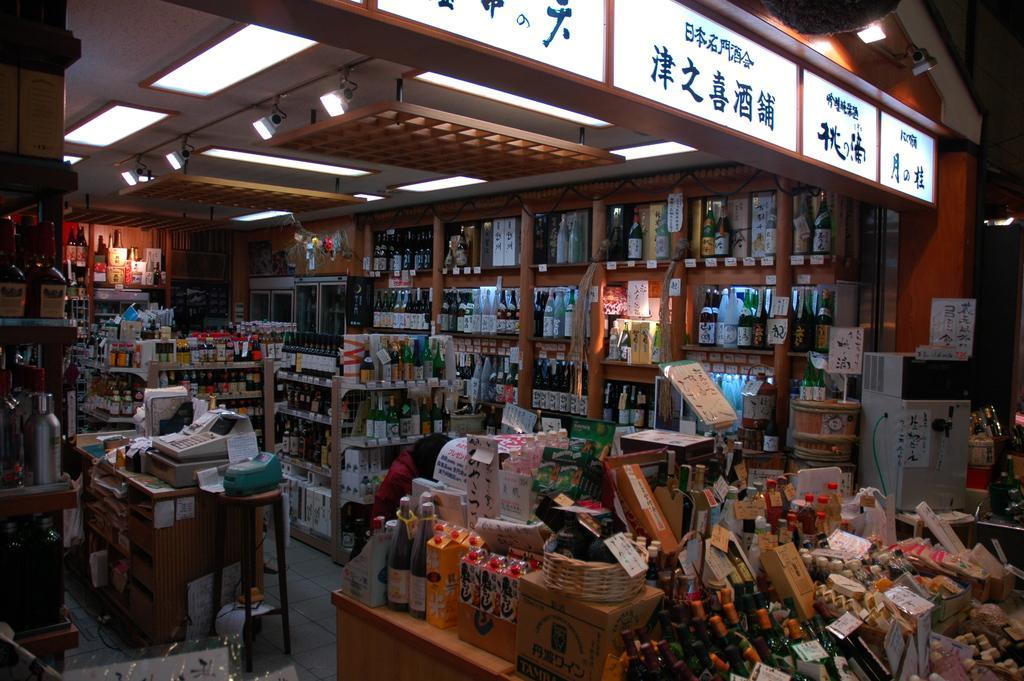Describe this image in one or two sentences. The picture looks like it is taken inside a wine store. In the image we can see various bottles in the shelves and racks. On the left we can see stool, table, papers and a machine. At the top we can see light, ceiling and a board. 